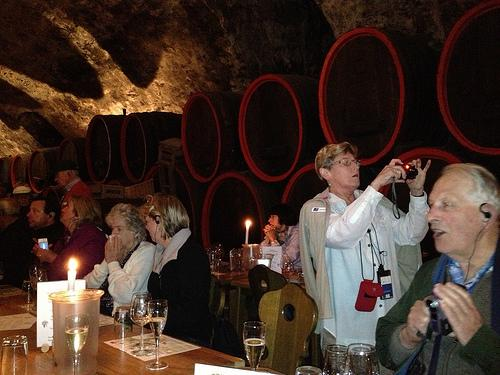Briefly describe the scene involving a woman blowing her nose. A woman with a white sweater is blowing her nose while sitting at a table. Give a description of the chairs in the image and their characteristics. There are wooden chairs with holes for handles as well as an empty wooden chair - both chairs are brown. Mention the objects placed on the table and their respective positions in the image. Wine glasses, champagne glasses, and lit candles are on the table, with the lit candles placed between the wine and champagne glasses. Identify the person who is taking a picture and describe their appearance. A woman wearing a white blouse is taking a picture with a red camera case around her neck. Provide an overview of the general setting and people present in the image. The image depicts people in a restaurant setting, with a woman taking pictures, a man with headphones, wine glasses, lit candles, and wine barrels lining a wall. What type of electronic device is the man with the green sweater using? The man with a green sweater is listening to an electronic device with headphones in his ear. Describe the appearance and location of any lit candles within the image. There is a lit white candle on a table, as well as a lit candle situated between wine glasses and champagne glasses. What is the appearance of the man wearing a red shirt? The man wearing a red shirt is an older man with a ball cap, possibly seated at a table. What is the significance of the barrels and their placement within the image? There are several red-rimmed wine barrels which are significant as they may indicate a winery or a restaurant with a wine theme, placed along a wall in the image. Explain what the man holding the camera is doing in the scene. The man is holding a camera, possibly taking a photo or recording video in a restaurant setting. There's a young boy wearing a red shirt sitting at a table. No, it's not mentioned in the image. Fetch the black camera bag lying on the floor. There's a red camera case around a woman's neck, but no mention of a black camera bag on the floor. Who is that lady wearing a blue dress sitting at a table on her own? The woman is described as wearing a white blouse or sweater, not a blue dress. Identify the tall man holding a professional movie camera. A man is described as holding a camera or cam recorder but does not mention the man being tall or the camera being a professional movie camera. Can you please adjust the volume of the radio sitting next to the man with the headset? There's a man with a headset in his ear, but no mention of a radio next to him. Can you find the yellow-rimmed barrels along the wall? The barrels are described as red-rimmed, not yellow-rimmed. Do you see the man wearing a blue sweater taking a video? The man who is taking a video is described as wearing a green sweater, not a blue one. Look for a woman taking a picture using a smartphone. The woman is described as taking a picture, but it doesn't mention using a smartphone. 